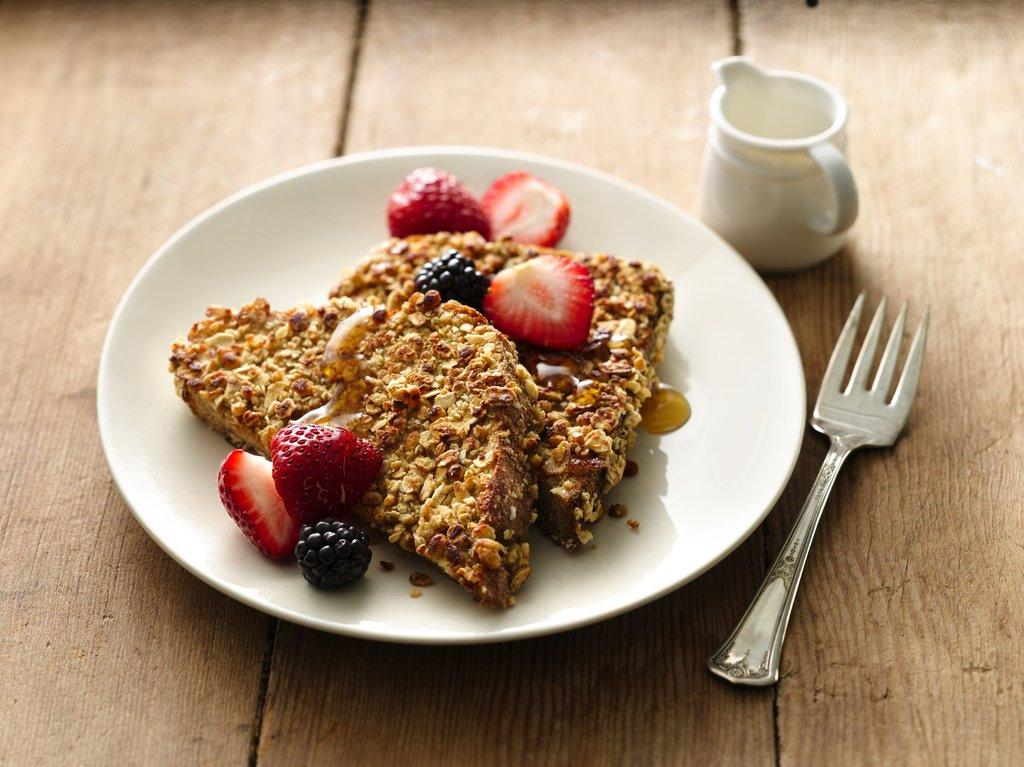What types of food items can be seen in the image? The food items in the image are in brown, pink, and black colors. What is the color of the plate in the image? The plate in the image is brown in color. What is the color of the cup in the image? The cup in the image is also brown in color. What utensil is present in the image? There is a spoon in the image. What is the color of the surface the items are on? The surface the items are on is brown in color. How many brothers are depicted in the image? There are no people, including brothers, present in the image. Can you provide an example of a food item that is not in the image? It is not possible to provide an example of a food item that is not in the image, as we only have information about the food items that are present. 